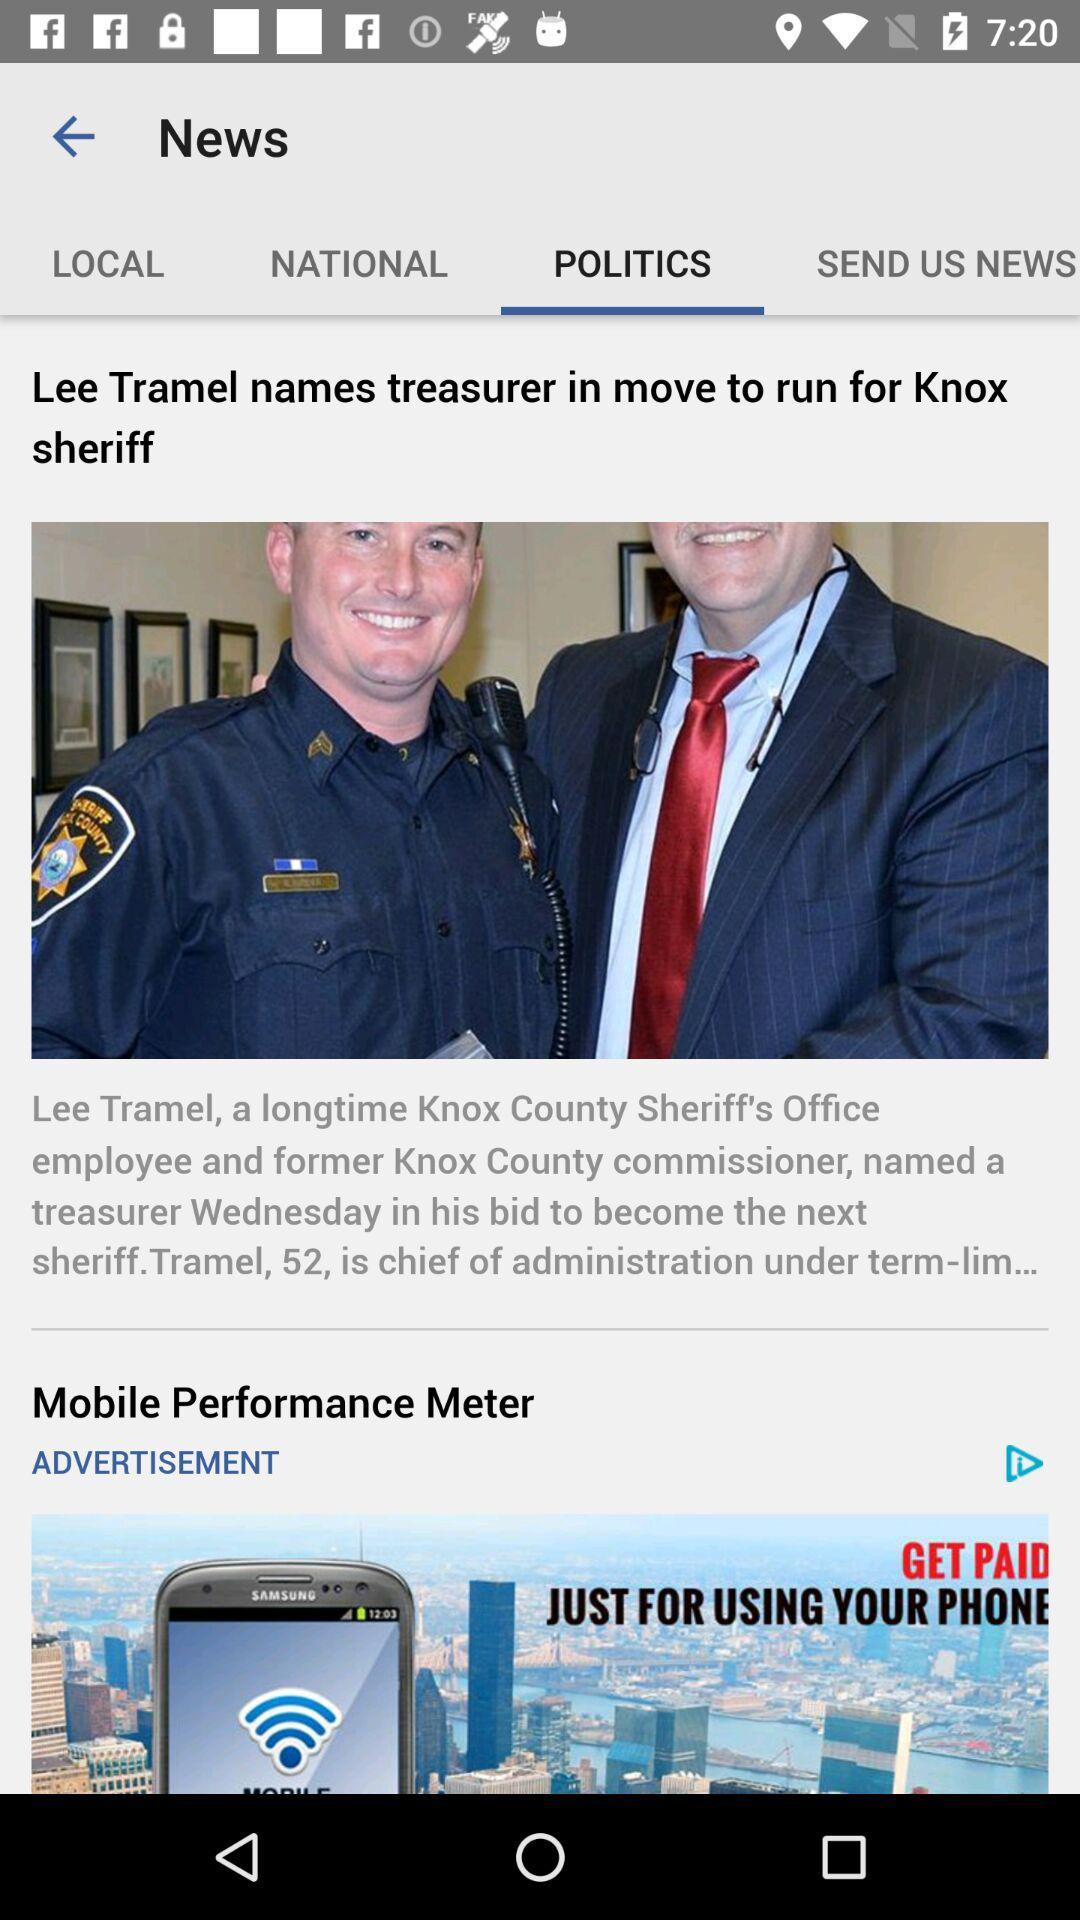What is the headline of the news? The headline of the news is "Lee Tramel names treasurer in move to run for Knox sheriff". 